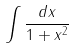<formula> <loc_0><loc_0><loc_500><loc_500>\int \frac { d x } { 1 + x ^ { 2 } }</formula> 